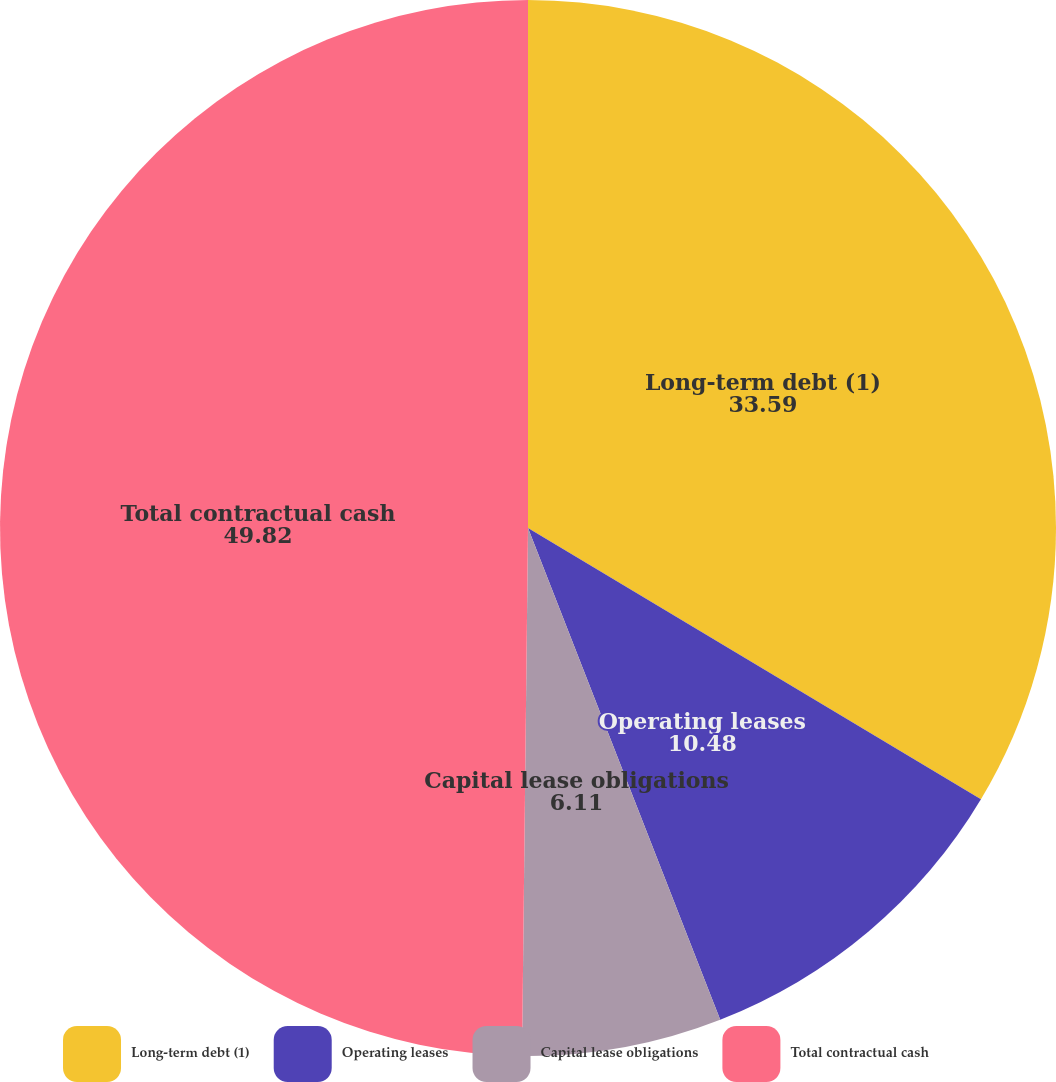<chart> <loc_0><loc_0><loc_500><loc_500><pie_chart><fcel>Long-term debt (1)<fcel>Operating leases<fcel>Capital lease obligations<fcel>Total contractual cash<nl><fcel>33.59%<fcel>10.48%<fcel>6.11%<fcel>49.82%<nl></chart> 